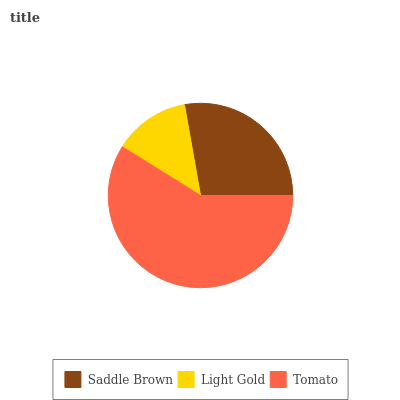Is Light Gold the minimum?
Answer yes or no. Yes. Is Tomato the maximum?
Answer yes or no. Yes. Is Tomato the minimum?
Answer yes or no. No. Is Light Gold the maximum?
Answer yes or no. No. Is Tomato greater than Light Gold?
Answer yes or no. Yes. Is Light Gold less than Tomato?
Answer yes or no. Yes. Is Light Gold greater than Tomato?
Answer yes or no. No. Is Tomato less than Light Gold?
Answer yes or no. No. Is Saddle Brown the high median?
Answer yes or no. Yes. Is Saddle Brown the low median?
Answer yes or no. Yes. Is Tomato the high median?
Answer yes or no. No. Is Tomato the low median?
Answer yes or no. No. 